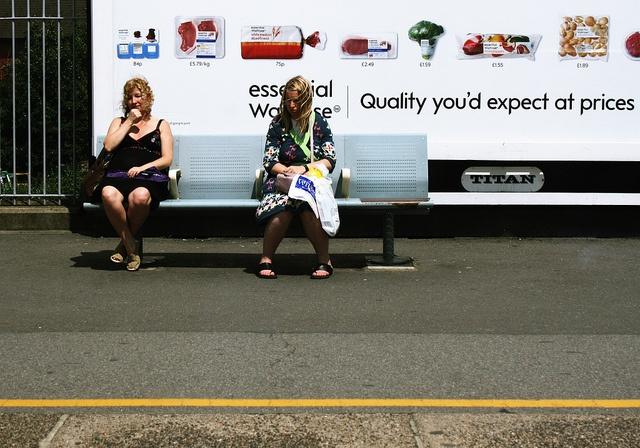Describe the objects in this image and their specific colors. I can see bench in black, lightblue, darkgray, gray, and lightgray tones, people in black, tan, and maroon tones, people in black, lightgray, maroon, and gray tones, handbag in black, navy, purple, and gray tones, and handbag in black, gray, maroon, and darkgreen tones in this image. 